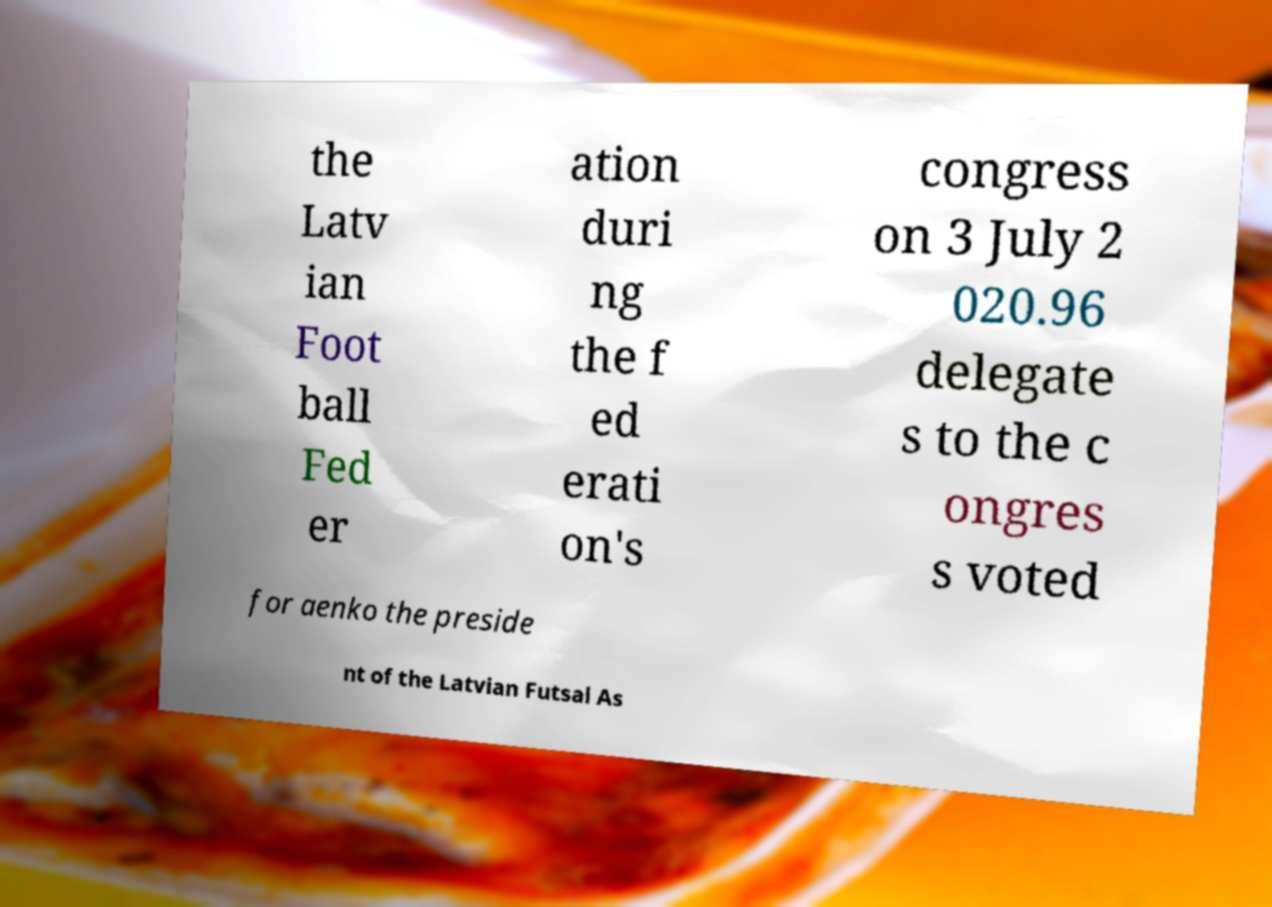Please identify and transcribe the text found in this image. the Latv ian Foot ball Fed er ation duri ng the f ed erati on's congress on 3 July 2 020.96 delegate s to the c ongres s voted for aenko the preside nt of the Latvian Futsal As 